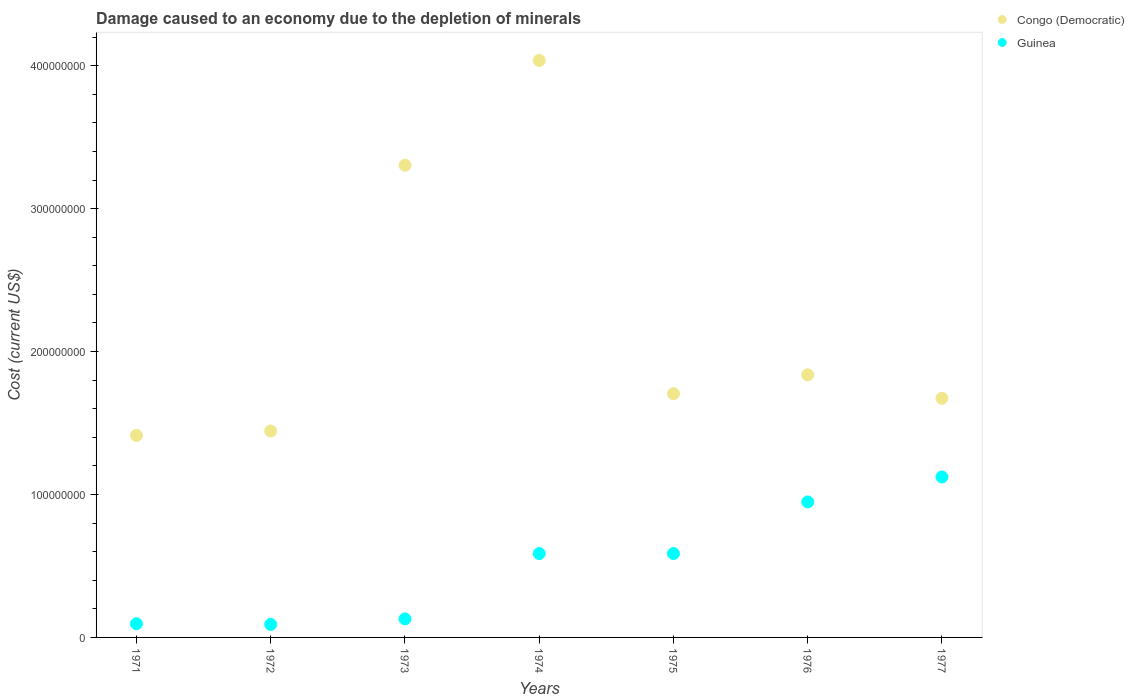How many different coloured dotlines are there?
Offer a very short reply. 2. What is the cost of damage caused due to the depletion of minerals in Guinea in 1974?
Keep it short and to the point. 5.87e+07. Across all years, what is the maximum cost of damage caused due to the depletion of minerals in Congo (Democratic)?
Provide a succinct answer. 4.04e+08. Across all years, what is the minimum cost of damage caused due to the depletion of minerals in Congo (Democratic)?
Provide a short and direct response. 1.41e+08. In which year was the cost of damage caused due to the depletion of minerals in Guinea maximum?
Provide a short and direct response. 1977. In which year was the cost of damage caused due to the depletion of minerals in Congo (Democratic) minimum?
Ensure brevity in your answer.  1971. What is the total cost of damage caused due to the depletion of minerals in Guinea in the graph?
Make the answer very short. 3.56e+08. What is the difference between the cost of damage caused due to the depletion of minerals in Guinea in 1971 and that in 1976?
Ensure brevity in your answer.  -8.52e+07. What is the difference between the cost of damage caused due to the depletion of minerals in Guinea in 1975 and the cost of damage caused due to the depletion of minerals in Congo (Democratic) in 1976?
Provide a succinct answer. -1.25e+08. What is the average cost of damage caused due to the depletion of minerals in Guinea per year?
Your answer should be very brief. 5.09e+07. In the year 1974, what is the difference between the cost of damage caused due to the depletion of minerals in Congo (Democratic) and cost of damage caused due to the depletion of minerals in Guinea?
Ensure brevity in your answer.  3.45e+08. In how many years, is the cost of damage caused due to the depletion of minerals in Guinea greater than 280000000 US$?
Provide a short and direct response. 0. What is the ratio of the cost of damage caused due to the depletion of minerals in Congo (Democratic) in 1972 to that in 1976?
Your answer should be very brief. 0.79. Is the cost of damage caused due to the depletion of minerals in Congo (Democratic) in 1973 less than that in 1977?
Give a very brief answer. No. Is the difference between the cost of damage caused due to the depletion of minerals in Congo (Democratic) in 1975 and 1976 greater than the difference between the cost of damage caused due to the depletion of minerals in Guinea in 1975 and 1976?
Make the answer very short. Yes. What is the difference between the highest and the second highest cost of damage caused due to the depletion of minerals in Guinea?
Offer a terse response. 1.75e+07. What is the difference between the highest and the lowest cost of damage caused due to the depletion of minerals in Congo (Democratic)?
Ensure brevity in your answer.  2.62e+08. Is the cost of damage caused due to the depletion of minerals in Congo (Democratic) strictly greater than the cost of damage caused due to the depletion of minerals in Guinea over the years?
Keep it short and to the point. Yes. What is the difference between two consecutive major ticks on the Y-axis?
Offer a terse response. 1.00e+08. Are the values on the major ticks of Y-axis written in scientific E-notation?
Offer a terse response. No. Does the graph contain any zero values?
Offer a terse response. No. Does the graph contain grids?
Give a very brief answer. No. How many legend labels are there?
Provide a succinct answer. 2. What is the title of the graph?
Your answer should be compact. Damage caused to an economy due to the depletion of minerals. What is the label or title of the Y-axis?
Your response must be concise. Cost (current US$). What is the Cost (current US$) in Congo (Democratic) in 1971?
Your response must be concise. 1.41e+08. What is the Cost (current US$) in Guinea in 1971?
Your answer should be very brief. 9.59e+06. What is the Cost (current US$) in Congo (Democratic) in 1972?
Make the answer very short. 1.44e+08. What is the Cost (current US$) of Guinea in 1972?
Ensure brevity in your answer.  9.08e+06. What is the Cost (current US$) in Congo (Democratic) in 1973?
Ensure brevity in your answer.  3.30e+08. What is the Cost (current US$) in Guinea in 1973?
Offer a very short reply. 1.30e+07. What is the Cost (current US$) of Congo (Democratic) in 1974?
Make the answer very short. 4.04e+08. What is the Cost (current US$) of Guinea in 1974?
Provide a succinct answer. 5.87e+07. What is the Cost (current US$) of Congo (Democratic) in 1975?
Offer a terse response. 1.70e+08. What is the Cost (current US$) of Guinea in 1975?
Provide a succinct answer. 5.87e+07. What is the Cost (current US$) of Congo (Democratic) in 1976?
Ensure brevity in your answer.  1.84e+08. What is the Cost (current US$) of Guinea in 1976?
Your response must be concise. 9.48e+07. What is the Cost (current US$) of Congo (Democratic) in 1977?
Offer a terse response. 1.67e+08. What is the Cost (current US$) of Guinea in 1977?
Offer a very short reply. 1.12e+08. Across all years, what is the maximum Cost (current US$) of Congo (Democratic)?
Offer a very short reply. 4.04e+08. Across all years, what is the maximum Cost (current US$) of Guinea?
Your answer should be compact. 1.12e+08. Across all years, what is the minimum Cost (current US$) in Congo (Democratic)?
Make the answer very short. 1.41e+08. Across all years, what is the minimum Cost (current US$) of Guinea?
Your answer should be very brief. 9.08e+06. What is the total Cost (current US$) in Congo (Democratic) in the graph?
Give a very brief answer. 1.54e+09. What is the total Cost (current US$) of Guinea in the graph?
Offer a very short reply. 3.56e+08. What is the difference between the Cost (current US$) in Congo (Democratic) in 1971 and that in 1972?
Provide a short and direct response. -3.11e+06. What is the difference between the Cost (current US$) in Guinea in 1971 and that in 1972?
Your answer should be very brief. 5.15e+05. What is the difference between the Cost (current US$) in Congo (Democratic) in 1971 and that in 1973?
Offer a terse response. -1.89e+08. What is the difference between the Cost (current US$) of Guinea in 1971 and that in 1973?
Provide a short and direct response. -3.39e+06. What is the difference between the Cost (current US$) in Congo (Democratic) in 1971 and that in 1974?
Ensure brevity in your answer.  -2.62e+08. What is the difference between the Cost (current US$) of Guinea in 1971 and that in 1974?
Offer a terse response. -4.91e+07. What is the difference between the Cost (current US$) of Congo (Democratic) in 1971 and that in 1975?
Provide a short and direct response. -2.92e+07. What is the difference between the Cost (current US$) of Guinea in 1971 and that in 1975?
Give a very brief answer. -4.91e+07. What is the difference between the Cost (current US$) of Congo (Democratic) in 1971 and that in 1976?
Provide a short and direct response. -4.24e+07. What is the difference between the Cost (current US$) in Guinea in 1971 and that in 1976?
Offer a terse response. -8.52e+07. What is the difference between the Cost (current US$) in Congo (Democratic) in 1971 and that in 1977?
Offer a very short reply. -2.60e+07. What is the difference between the Cost (current US$) in Guinea in 1971 and that in 1977?
Your answer should be very brief. -1.03e+08. What is the difference between the Cost (current US$) in Congo (Democratic) in 1972 and that in 1973?
Make the answer very short. -1.86e+08. What is the difference between the Cost (current US$) of Guinea in 1972 and that in 1973?
Provide a succinct answer. -3.90e+06. What is the difference between the Cost (current US$) of Congo (Democratic) in 1972 and that in 1974?
Make the answer very short. -2.59e+08. What is the difference between the Cost (current US$) of Guinea in 1972 and that in 1974?
Provide a succinct answer. -4.96e+07. What is the difference between the Cost (current US$) of Congo (Democratic) in 1972 and that in 1975?
Keep it short and to the point. -2.61e+07. What is the difference between the Cost (current US$) of Guinea in 1972 and that in 1975?
Give a very brief answer. -4.96e+07. What is the difference between the Cost (current US$) in Congo (Democratic) in 1972 and that in 1976?
Your answer should be very brief. -3.93e+07. What is the difference between the Cost (current US$) of Guinea in 1972 and that in 1976?
Make the answer very short. -8.57e+07. What is the difference between the Cost (current US$) of Congo (Democratic) in 1972 and that in 1977?
Your response must be concise. -2.29e+07. What is the difference between the Cost (current US$) in Guinea in 1972 and that in 1977?
Your response must be concise. -1.03e+08. What is the difference between the Cost (current US$) of Congo (Democratic) in 1973 and that in 1974?
Offer a terse response. -7.33e+07. What is the difference between the Cost (current US$) in Guinea in 1973 and that in 1974?
Make the answer very short. -4.57e+07. What is the difference between the Cost (current US$) in Congo (Democratic) in 1973 and that in 1975?
Provide a succinct answer. 1.60e+08. What is the difference between the Cost (current US$) of Guinea in 1973 and that in 1975?
Give a very brief answer. -4.57e+07. What is the difference between the Cost (current US$) of Congo (Democratic) in 1973 and that in 1976?
Your response must be concise. 1.47e+08. What is the difference between the Cost (current US$) of Guinea in 1973 and that in 1976?
Give a very brief answer. -8.18e+07. What is the difference between the Cost (current US$) of Congo (Democratic) in 1973 and that in 1977?
Your answer should be compact. 1.63e+08. What is the difference between the Cost (current US$) in Guinea in 1973 and that in 1977?
Ensure brevity in your answer.  -9.93e+07. What is the difference between the Cost (current US$) in Congo (Democratic) in 1974 and that in 1975?
Give a very brief answer. 2.33e+08. What is the difference between the Cost (current US$) of Guinea in 1974 and that in 1975?
Offer a very short reply. -1.18e+04. What is the difference between the Cost (current US$) of Congo (Democratic) in 1974 and that in 1976?
Give a very brief answer. 2.20e+08. What is the difference between the Cost (current US$) in Guinea in 1974 and that in 1976?
Your answer should be very brief. -3.61e+07. What is the difference between the Cost (current US$) of Congo (Democratic) in 1974 and that in 1977?
Your answer should be compact. 2.36e+08. What is the difference between the Cost (current US$) of Guinea in 1974 and that in 1977?
Your answer should be compact. -5.36e+07. What is the difference between the Cost (current US$) in Congo (Democratic) in 1975 and that in 1976?
Make the answer very short. -1.32e+07. What is the difference between the Cost (current US$) in Guinea in 1975 and that in 1976?
Your answer should be compact. -3.61e+07. What is the difference between the Cost (current US$) in Congo (Democratic) in 1975 and that in 1977?
Provide a short and direct response. 3.18e+06. What is the difference between the Cost (current US$) of Guinea in 1975 and that in 1977?
Offer a terse response. -5.35e+07. What is the difference between the Cost (current US$) in Congo (Democratic) in 1976 and that in 1977?
Offer a very short reply. 1.64e+07. What is the difference between the Cost (current US$) of Guinea in 1976 and that in 1977?
Your answer should be very brief. -1.75e+07. What is the difference between the Cost (current US$) of Congo (Democratic) in 1971 and the Cost (current US$) of Guinea in 1972?
Your answer should be very brief. 1.32e+08. What is the difference between the Cost (current US$) in Congo (Democratic) in 1971 and the Cost (current US$) in Guinea in 1973?
Keep it short and to the point. 1.28e+08. What is the difference between the Cost (current US$) in Congo (Democratic) in 1971 and the Cost (current US$) in Guinea in 1974?
Offer a very short reply. 8.26e+07. What is the difference between the Cost (current US$) of Congo (Democratic) in 1971 and the Cost (current US$) of Guinea in 1975?
Make the answer very short. 8.26e+07. What is the difference between the Cost (current US$) in Congo (Democratic) in 1971 and the Cost (current US$) in Guinea in 1976?
Ensure brevity in your answer.  4.65e+07. What is the difference between the Cost (current US$) in Congo (Democratic) in 1971 and the Cost (current US$) in Guinea in 1977?
Ensure brevity in your answer.  2.91e+07. What is the difference between the Cost (current US$) of Congo (Democratic) in 1972 and the Cost (current US$) of Guinea in 1973?
Offer a terse response. 1.31e+08. What is the difference between the Cost (current US$) in Congo (Democratic) in 1972 and the Cost (current US$) in Guinea in 1974?
Give a very brief answer. 8.57e+07. What is the difference between the Cost (current US$) in Congo (Democratic) in 1972 and the Cost (current US$) in Guinea in 1975?
Give a very brief answer. 8.57e+07. What is the difference between the Cost (current US$) in Congo (Democratic) in 1972 and the Cost (current US$) in Guinea in 1976?
Offer a very short reply. 4.96e+07. What is the difference between the Cost (current US$) of Congo (Democratic) in 1972 and the Cost (current US$) of Guinea in 1977?
Make the answer very short. 3.22e+07. What is the difference between the Cost (current US$) of Congo (Democratic) in 1973 and the Cost (current US$) of Guinea in 1974?
Keep it short and to the point. 2.72e+08. What is the difference between the Cost (current US$) of Congo (Democratic) in 1973 and the Cost (current US$) of Guinea in 1975?
Your answer should be very brief. 2.72e+08. What is the difference between the Cost (current US$) of Congo (Democratic) in 1973 and the Cost (current US$) of Guinea in 1976?
Your answer should be very brief. 2.36e+08. What is the difference between the Cost (current US$) of Congo (Democratic) in 1973 and the Cost (current US$) of Guinea in 1977?
Provide a succinct answer. 2.18e+08. What is the difference between the Cost (current US$) in Congo (Democratic) in 1974 and the Cost (current US$) in Guinea in 1975?
Offer a very short reply. 3.45e+08. What is the difference between the Cost (current US$) in Congo (Democratic) in 1974 and the Cost (current US$) in Guinea in 1976?
Keep it short and to the point. 3.09e+08. What is the difference between the Cost (current US$) of Congo (Democratic) in 1974 and the Cost (current US$) of Guinea in 1977?
Offer a terse response. 2.91e+08. What is the difference between the Cost (current US$) of Congo (Democratic) in 1975 and the Cost (current US$) of Guinea in 1976?
Offer a terse response. 7.57e+07. What is the difference between the Cost (current US$) of Congo (Democratic) in 1975 and the Cost (current US$) of Guinea in 1977?
Give a very brief answer. 5.82e+07. What is the difference between the Cost (current US$) of Congo (Democratic) in 1976 and the Cost (current US$) of Guinea in 1977?
Keep it short and to the point. 7.15e+07. What is the average Cost (current US$) in Congo (Democratic) per year?
Make the answer very short. 2.20e+08. What is the average Cost (current US$) of Guinea per year?
Your answer should be compact. 5.09e+07. In the year 1971, what is the difference between the Cost (current US$) of Congo (Democratic) and Cost (current US$) of Guinea?
Your response must be concise. 1.32e+08. In the year 1972, what is the difference between the Cost (current US$) of Congo (Democratic) and Cost (current US$) of Guinea?
Your answer should be very brief. 1.35e+08. In the year 1973, what is the difference between the Cost (current US$) in Congo (Democratic) and Cost (current US$) in Guinea?
Your response must be concise. 3.17e+08. In the year 1974, what is the difference between the Cost (current US$) in Congo (Democratic) and Cost (current US$) in Guinea?
Offer a terse response. 3.45e+08. In the year 1975, what is the difference between the Cost (current US$) in Congo (Democratic) and Cost (current US$) in Guinea?
Your answer should be very brief. 1.12e+08. In the year 1976, what is the difference between the Cost (current US$) of Congo (Democratic) and Cost (current US$) of Guinea?
Offer a terse response. 8.89e+07. In the year 1977, what is the difference between the Cost (current US$) in Congo (Democratic) and Cost (current US$) in Guinea?
Provide a short and direct response. 5.51e+07. What is the ratio of the Cost (current US$) of Congo (Democratic) in 1971 to that in 1972?
Keep it short and to the point. 0.98. What is the ratio of the Cost (current US$) of Guinea in 1971 to that in 1972?
Give a very brief answer. 1.06. What is the ratio of the Cost (current US$) in Congo (Democratic) in 1971 to that in 1973?
Make the answer very short. 0.43. What is the ratio of the Cost (current US$) of Guinea in 1971 to that in 1973?
Ensure brevity in your answer.  0.74. What is the ratio of the Cost (current US$) of Congo (Democratic) in 1971 to that in 1974?
Ensure brevity in your answer.  0.35. What is the ratio of the Cost (current US$) of Guinea in 1971 to that in 1974?
Offer a very short reply. 0.16. What is the ratio of the Cost (current US$) in Congo (Democratic) in 1971 to that in 1975?
Provide a short and direct response. 0.83. What is the ratio of the Cost (current US$) in Guinea in 1971 to that in 1975?
Provide a succinct answer. 0.16. What is the ratio of the Cost (current US$) in Congo (Democratic) in 1971 to that in 1976?
Offer a terse response. 0.77. What is the ratio of the Cost (current US$) of Guinea in 1971 to that in 1976?
Keep it short and to the point. 0.1. What is the ratio of the Cost (current US$) of Congo (Democratic) in 1971 to that in 1977?
Provide a succinct answer. 0.84. What is the ratio of the Cost (current US$) of Guinea in 1971 to that in 1977?
Provide a short and direct response. 0.09. What is the ratio of the Cost (current US$) of Congo (Democratic) in 1972 to that in 1973?
Provide a short and direct response. 0.44. What is the ratio of the Cost (current US$) in Guinea in 1972 to that in 1973?
Make the answer very short. 0.7. What is the ratio of the Cost (current US$) in Congo (Democratic) in 1972 to that in 1974?
Offer a terse response. 0.36. What is the ratio of the Cost (current US$) of Guinea in 1972 to that in 1974?
Keep it short and to the point. 0.15. What is the ratio of the Cost (current US$) in Congo (Democratic) in 1972 to that in 1975?
Keep it short and to the point. 0.85. What is the ratio of the Cost (current US$) of Guinea in 1972 to that in 1975?
Your answer should be compact. 0.15. What is the ratio of the Cost (current US$) in Congo (Democratic) in 1972 to that in 1976?
Offer a very short reply. 0.79. What is the ratio of the Cost (current US$) of Guinea in 1972 to that in 1976?
Your response must be concise. 0.1. What is the ratio of the Cost (current US$) in Congo (Democratic) in 1972 to that in 1977?
Your response must be concise. 0.86. What is the ratio of the Cost (current US$) in Guinea in 1972 to that in 1977?
Your response must be concise. 0.08. What is the ratio of the Cost (current US$) of Congo (Democratic) in 1973 to that in 1974?
Your response must be concise. 0.82. What is the ratio of the Cost (current US$) of Guinea in 1973 to that in 1974?
Your answer should be very brief. 0.22. What is the ratio of the Cost (current US$) of Congo (Democratic) in 1973 to that in 1975?
Your response must be concise. 1.94. What is the ratio of the Cost (current US$) in Guinea in 1973 to that in 1975?
Give a very brief answer. 0.22. What is the ratio of the Cost (current US$) of Congo (Democratic) in 1973 to that in 1976?
Keep it short and to the point. 1.8. What is the ratio of the Cost (current US$) of Guinea in 1973 to that in 1976?
Provide a succinct answer. 0.14. What is the ratio of the Cost (current US$) in Congo (Democratic) in 1973 to that in 1977?
Provide a succinct answer. 1.97. What is the ratio of the Cost (current US$) of Guinea in 1973 to that in 1977?
Provide a succinct answer. 0.12. What is the ratio of the Cost (current US$) of Congo (Democratic) in 1974 to that in 1975?
Provide a short and direct response. 2.37. What is the ratio of the Cost (current US$) in Congo (Democratic) in 1974 to that in 1976?
Offer a terse response. 2.2. What is the ratio of the Cost (current US$) of Guinea in 1974 to that in 1976?
Make the answer very short. 0.62. What is the ratio of the Cost (current US$) of Congo (Democratic) in 1974 to that in 1977?
Keep it short and to the point. 2.41. What is the ratio of the Cost (current US$) in Guinea in 1974 to that in 1977?
Your response must be concise. 0.52. What is the ratio of the Cost (current US$) in Congo (Democratic) in 1975 to that in 1976?
Give a very brief answer. 0.93. What is the ratio of the Cost (current US$) of Guinea in 1975 to that in 1976?
Provide a short and direct response. 0.62. What is the ratio of the Cost (current US$) in Congo (Democratic) in 1975 to that in 1977?
Offer a very short reply. 1.02. What is the ratio of the Cost (current US$) in Guinea in 1975 to that in 1977?
Your answer should be compact. 0.52. What is the ratio of the Cost (current US$) in Congo (Democratic) in 1976 to that in 1977?
Offer a very short reply. 1.1. What is the ratio of the Cost (current US$) of Guinea in 1976 to that in 1977?
Ensure brevity in your answer.  0.84. What is the difference between the highest and the second highest Cost (current US$) of Congo (Democratic)?
Provide a short and direct response. 7.33e+07. What is the difference between the highest and the second highest Cost (current US$) in Guinea?
Provide a short and direct response. 1.75e+07. What is the difference between the highest and the lowest Cost (current US$) of Congo (Democratic)?
Provide a succinct answer. 2.62e+08. What is the difference between the highest and the lowest Cost (current US$) of Guinea?
Offer a terse response. 1.03e+08. 